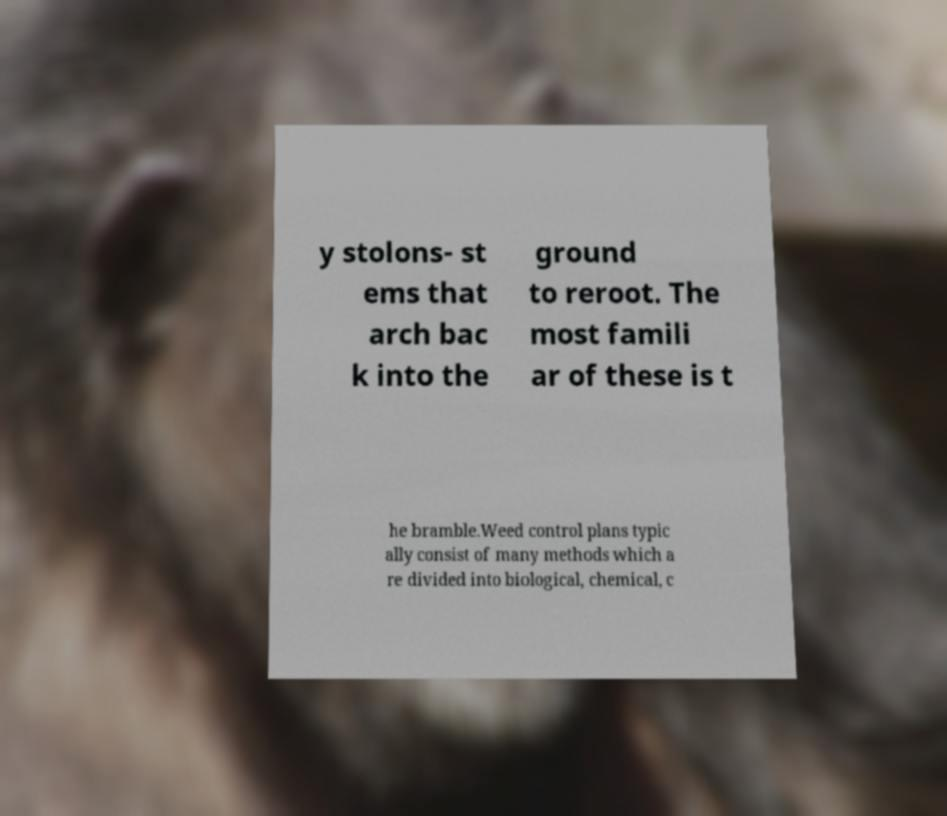Please read and relay the text visible in this image. What does it say? y stolons- st ems that arch bac k into the ground to reroot. The most famili ar of these is t he bramble.Weed control plans typic ally consist of many methods which a re divided into biological, chemical, c 